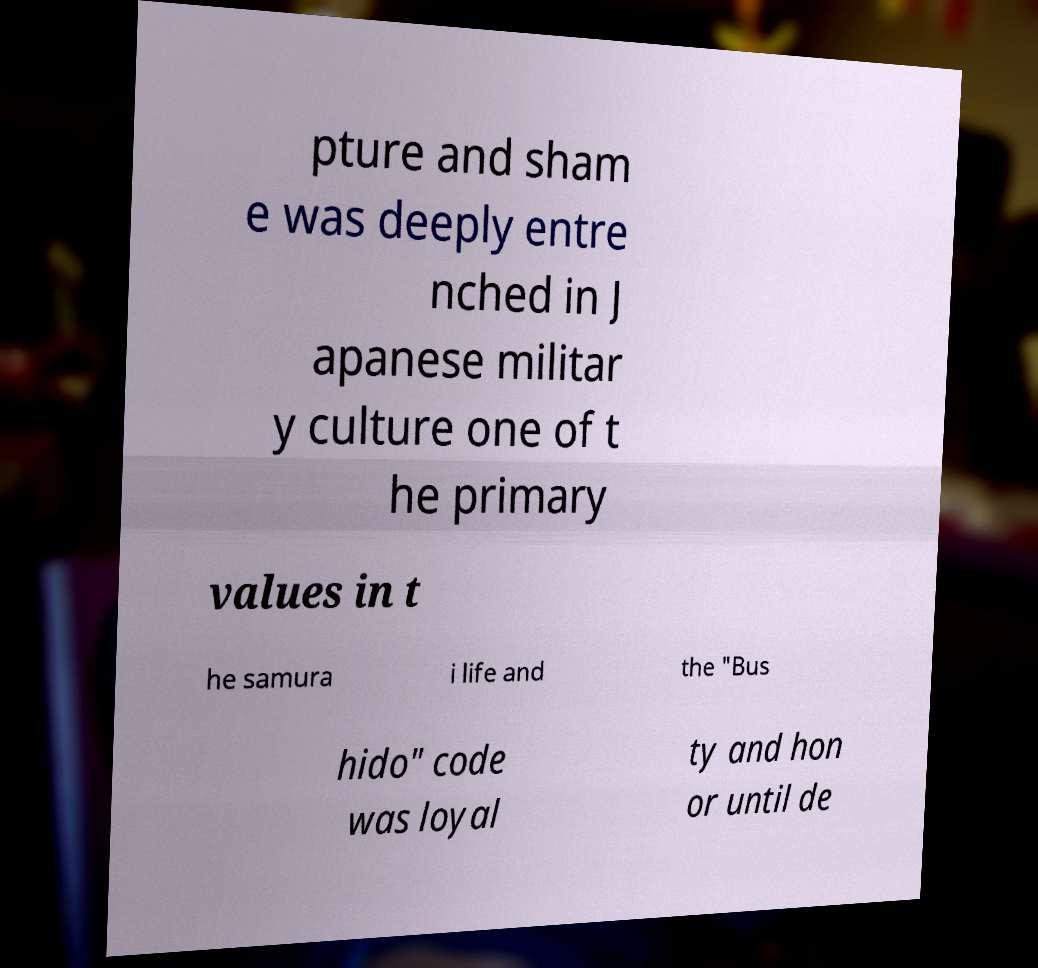I need the written content from this picture converted into text. Can you do that? pture and sham e was deeply entre nched in J apanese militar y culture one of t he primary values in t he samura i life and the "Bus hido" code was loyal ty and hon or until de 